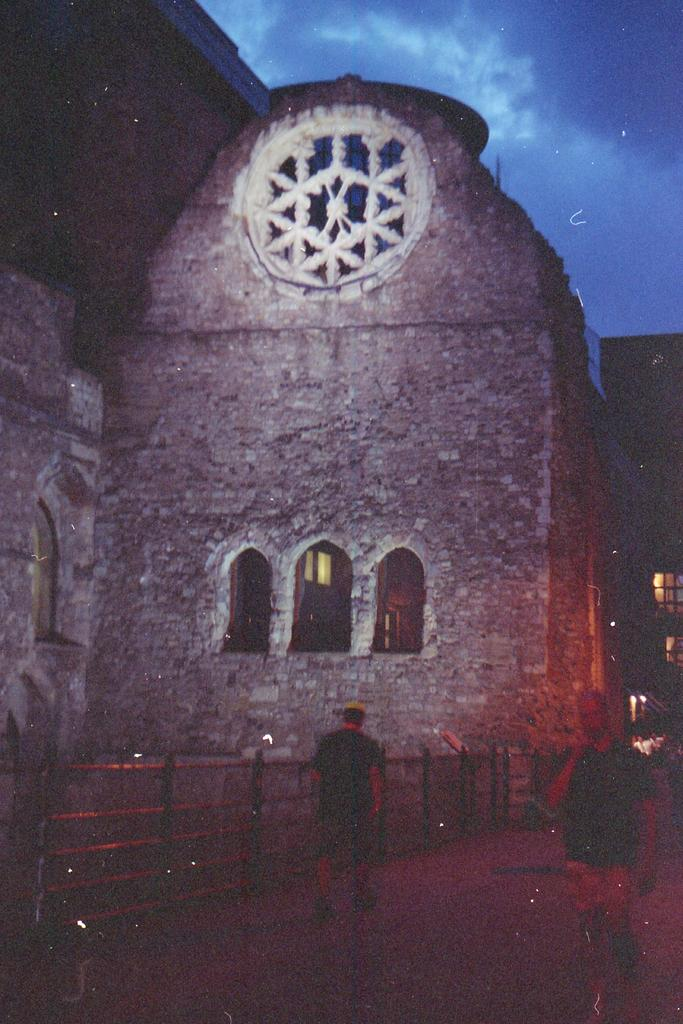What type of structure is visible at the front of the image? There is an arch wall in the front of the image. What can be seen at the bottom of the image? There is fencing railing on the bottom side of the image. What are the two persons in the image doing? Two persons are walking in the pedestrian area. What type of music can be heard playing in the background of the image? There is no music present in the image, as it only shows an arch wall, fencing railing, and two persons walking. 